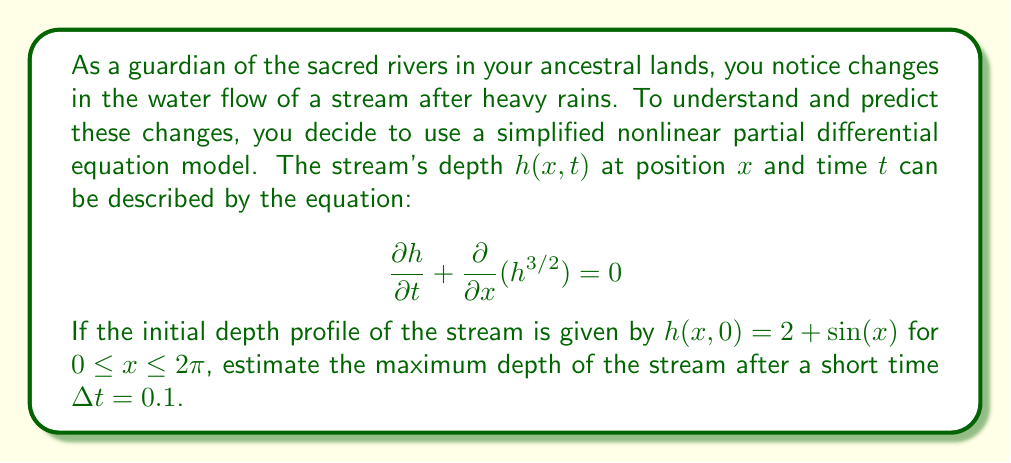Show me your answer to this math problem. To estimate the maximum depth of the stream after a short time, we'll use the method of characteristics for the given nonlinear partial differential equation.

1) The equation can be written in the form:

   $$\frac{\partial h}{\partial t} + \frac{3}{2}h^{1/2}\frac{\partial h}{\partial x} = 0$$

2) The characteristic speed is $c(h) = \frac{3}{2}h^{1/2}$.

3) Along the characteristics, $h$ remains constant. The characteristics are given by:

   $$\frac{dx}{dt} = c(h) = \frac{3}{2}h^{1/2}$$

4) For a small time $\Delta t$, the characteristics will shift the initial profile by approximately $c(h)\Delta t$.

5) The maximum depth will occur where the initial profile was highest, which is at $x = \pi/2$ where $h(x,0) = 3$.

6) At this point, the characteristic speed is:

   $$c(3) = \frac{3}{2}(3)^{1/2} = \frac{3\sqrt{3}}{2}$$

7) The shift in x-direction after time $\Delta t = 0.1$ is:

   $$\Delta x = c(3)\Delta t = \frac{3\sqrt{3}}{2} \cdot 0.1 \approx 0.2598$$

8) This small shift won't significantly change the maximum depth, so we can estimate that the maximum depth remains approximately 3.

Note: This is an estimate based on a short time interval. For longer times or more precise results, we would need to solve the equation numerically or use more advanced analytical techniques.
Answer: $h_{max} \approx 3$ 